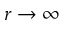Convert formula to latex. <formula><loc_0><loc_0><loc_500><loc_500>r \to \infty</formula> 